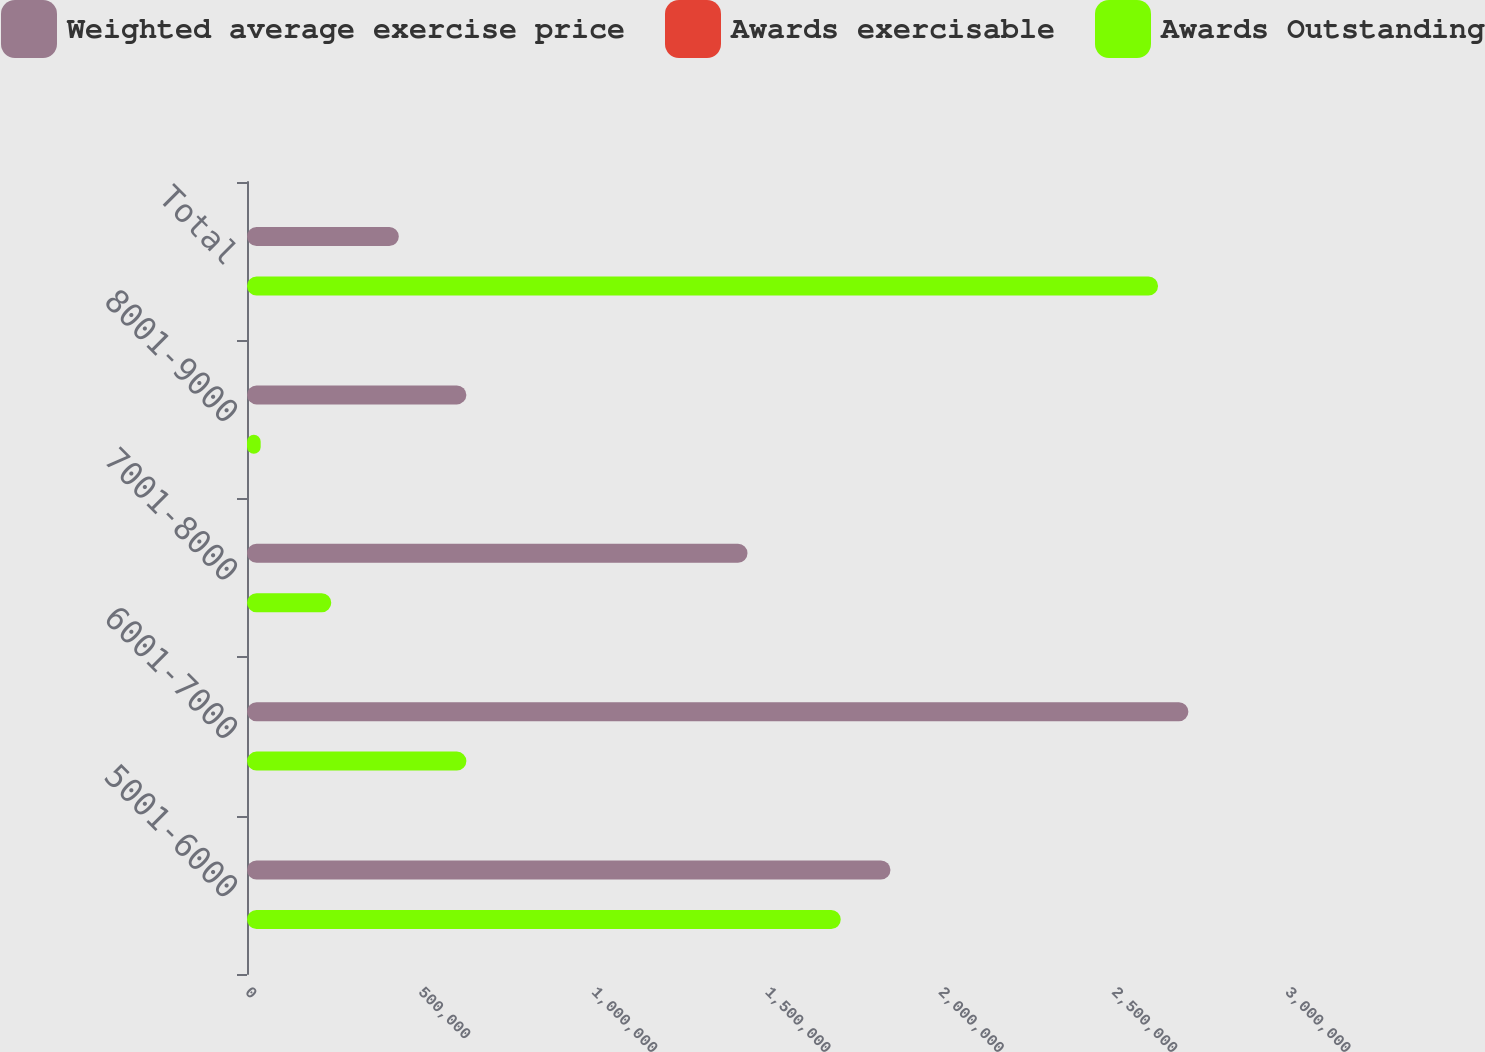Convert chart to OTSL. <chart><loc_0><loc_0><loc_500><loc_500><stacked_bar_chart><ecel><fcel>5001-6000<fcel>6001-7000<fcel>7001-8000<fcel>8001-9000<fcel>Total<nl><fcel>Weighted average exercise price<fcel>1.85614e+06<fcel>2.71554e+06<fcel>1.44375e+06<fcel>632763<fcel>437902<nl><fcel>Awards exercisable<fcel>59.05<fcel>66.7<fcel>74.77<fcel>83.59<fcel>67.92<nl><fcel>Awards Outstanding<fcel>1.71268e+06<fcel>632849<fcel>243041<fcel>39443<fcel>2.62801e+06<nl></chart> 